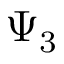<formula> <loc_0><loc_0><loc_500><loc_500>\Psi _ { 3 }</formula> 